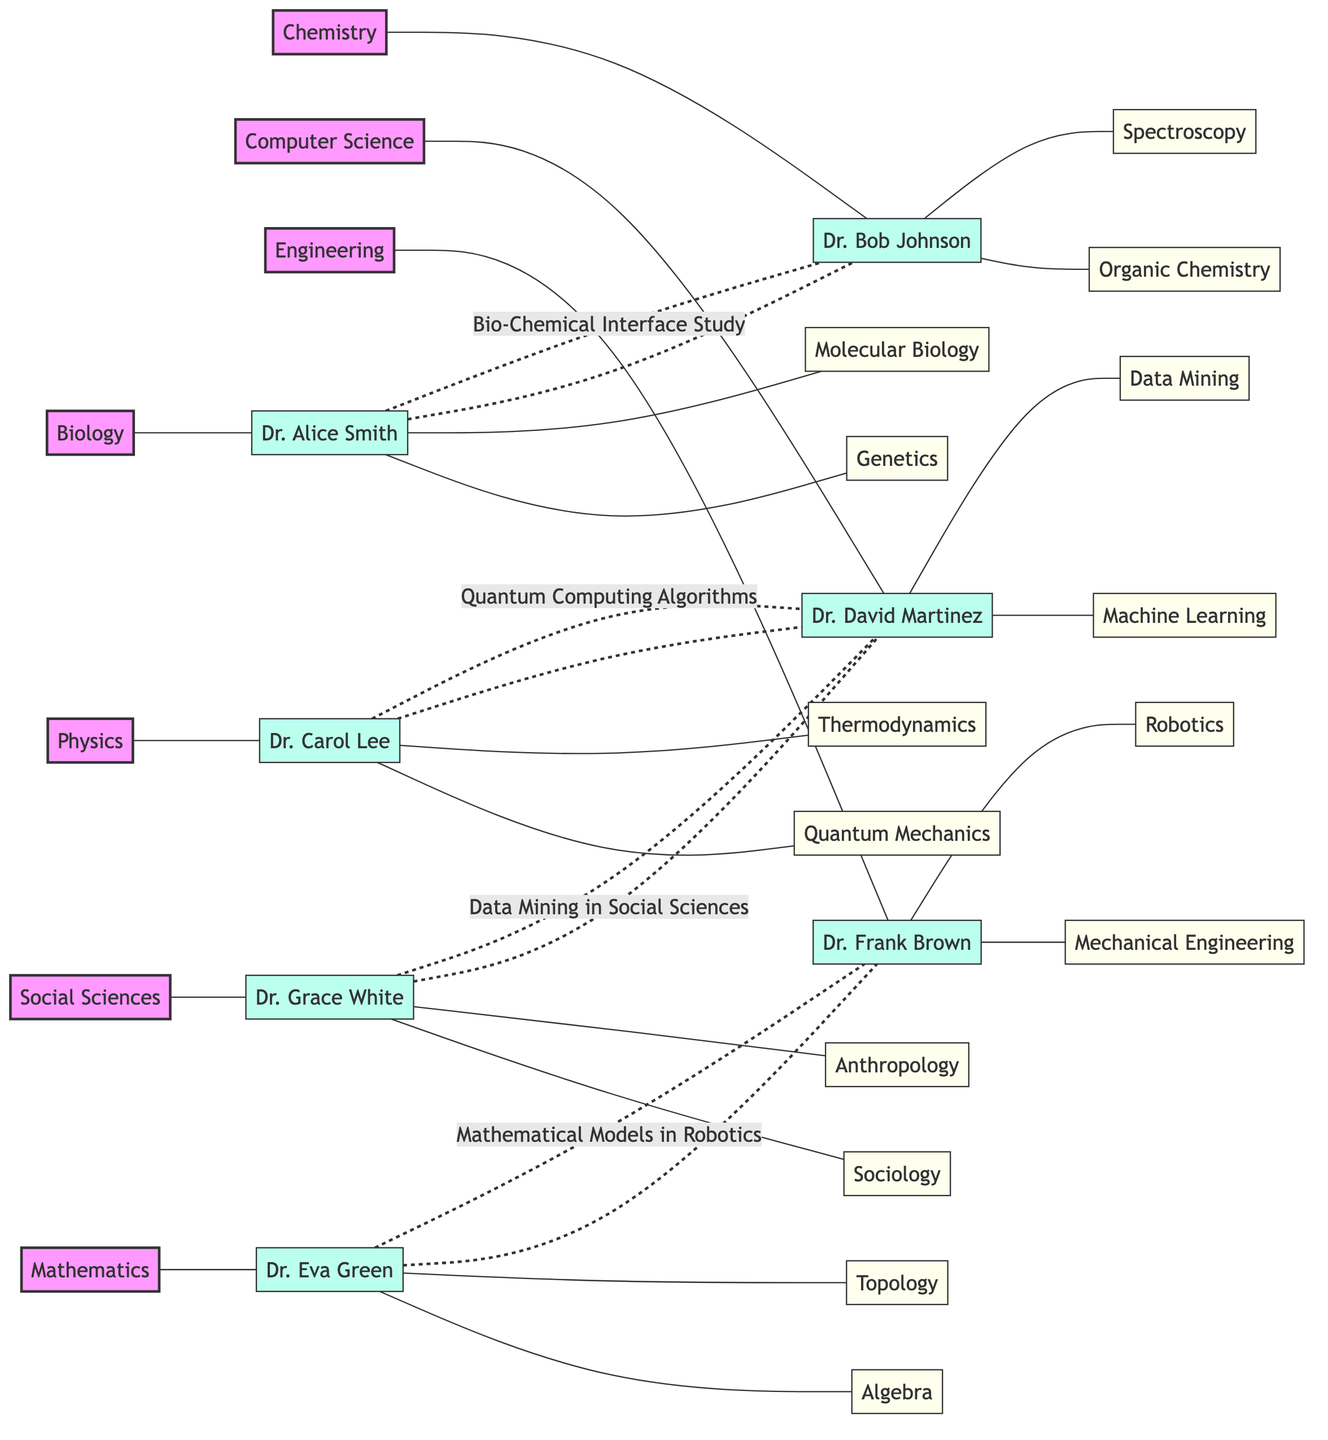What is the total number of departments represented in the diagram? The diagram includes a list of departments that are visually represented. By counting each unique department listed, we find that there are seven departments: Biology, Chemistry, Physics, Computer Science, Mathematics, Engineering, and Social Sciences.
Answer: 7 Which researcher specializes in Genetics? The diagram shows each researcher alongside their specialties. Dr. Alice Smith is explicitly listed under the Biology department with Genetics as one of her specialties.
Answer: Dr. Alice Smith What project are Dr. Carol Lee and Dr. David Martinez collaborating on? The diagram includes specific collaboration links between researchers, and it indicates that Dr. Carol Lee and Dr. David Martinez are collaborating on the project titled "Quantum Computing Algorithms."
Answer: Quantum Computing Algorithms How many collaborations involve Dr. David Martinez? By examining the collaboration links in the diagram, we see that Dr. David Martinez is involved in two separate collaborations: one with Dr. Carol Lee and another with Dr. Grace White. Thus, he has two collaborations.
Answer: 2 Which two researchers are connected by a dashed line representing a collaboration for "Data Mining in Social Sciences"? The diagram specifically visualizes collaborations with different line styles. The dashed line indicating the project "Data Mining in Social Sciences" connects Dr. Grace White and Dr. David Martinez.
Answer: Dr. Grace White and Dr. David Martinez What is the common specialty between Dr. Eva Green and Dr. Frank Brown? Looking at the diagram, Dr. Eva Green and Dr. Frank Brown are linked through their collaboration. Dr. Eva Green's specialties are Mathematics-related, and Dr. Frank Brown's include Mechanical Engineering and Robotics. Therefore, they do not share a common specialty.
Answer: None Which department does Dr. Bob Johnson belong to? Each researcher in the diagram is associated with a specific department. Dr. Bob Johnson is clearly listed under the Chemistry department.
Answer: Chemistry Identify one specialty of Dr. Frank Brown. The diagram lists Dr. Frank Brown's specialties, which include Mechanical Engineering and Robotics. One of these is sufficient to answer the question.
Answer: Mechanical Engineering 